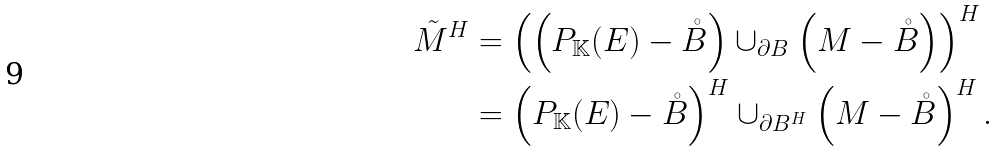<formula> <loc_0><loc_0><loc_500><loc_500>\tilde { M } ^ { H } & = \left ( \left ( P _ { \mathbb { K } } ( E ) - \mathring { B } \right ) \cup _ { \partial B } \left ( M - \mathring { B } \right ) \right ) ^ { H } \\ & = \left ( P _ { \mathbb { K } } ( E ) - \mathring { B } \right ) ^ { H } \cup _ { \partial B ^ { H } } \left ( M - \mathring { B } \right ) ^ { H } .</formula> 